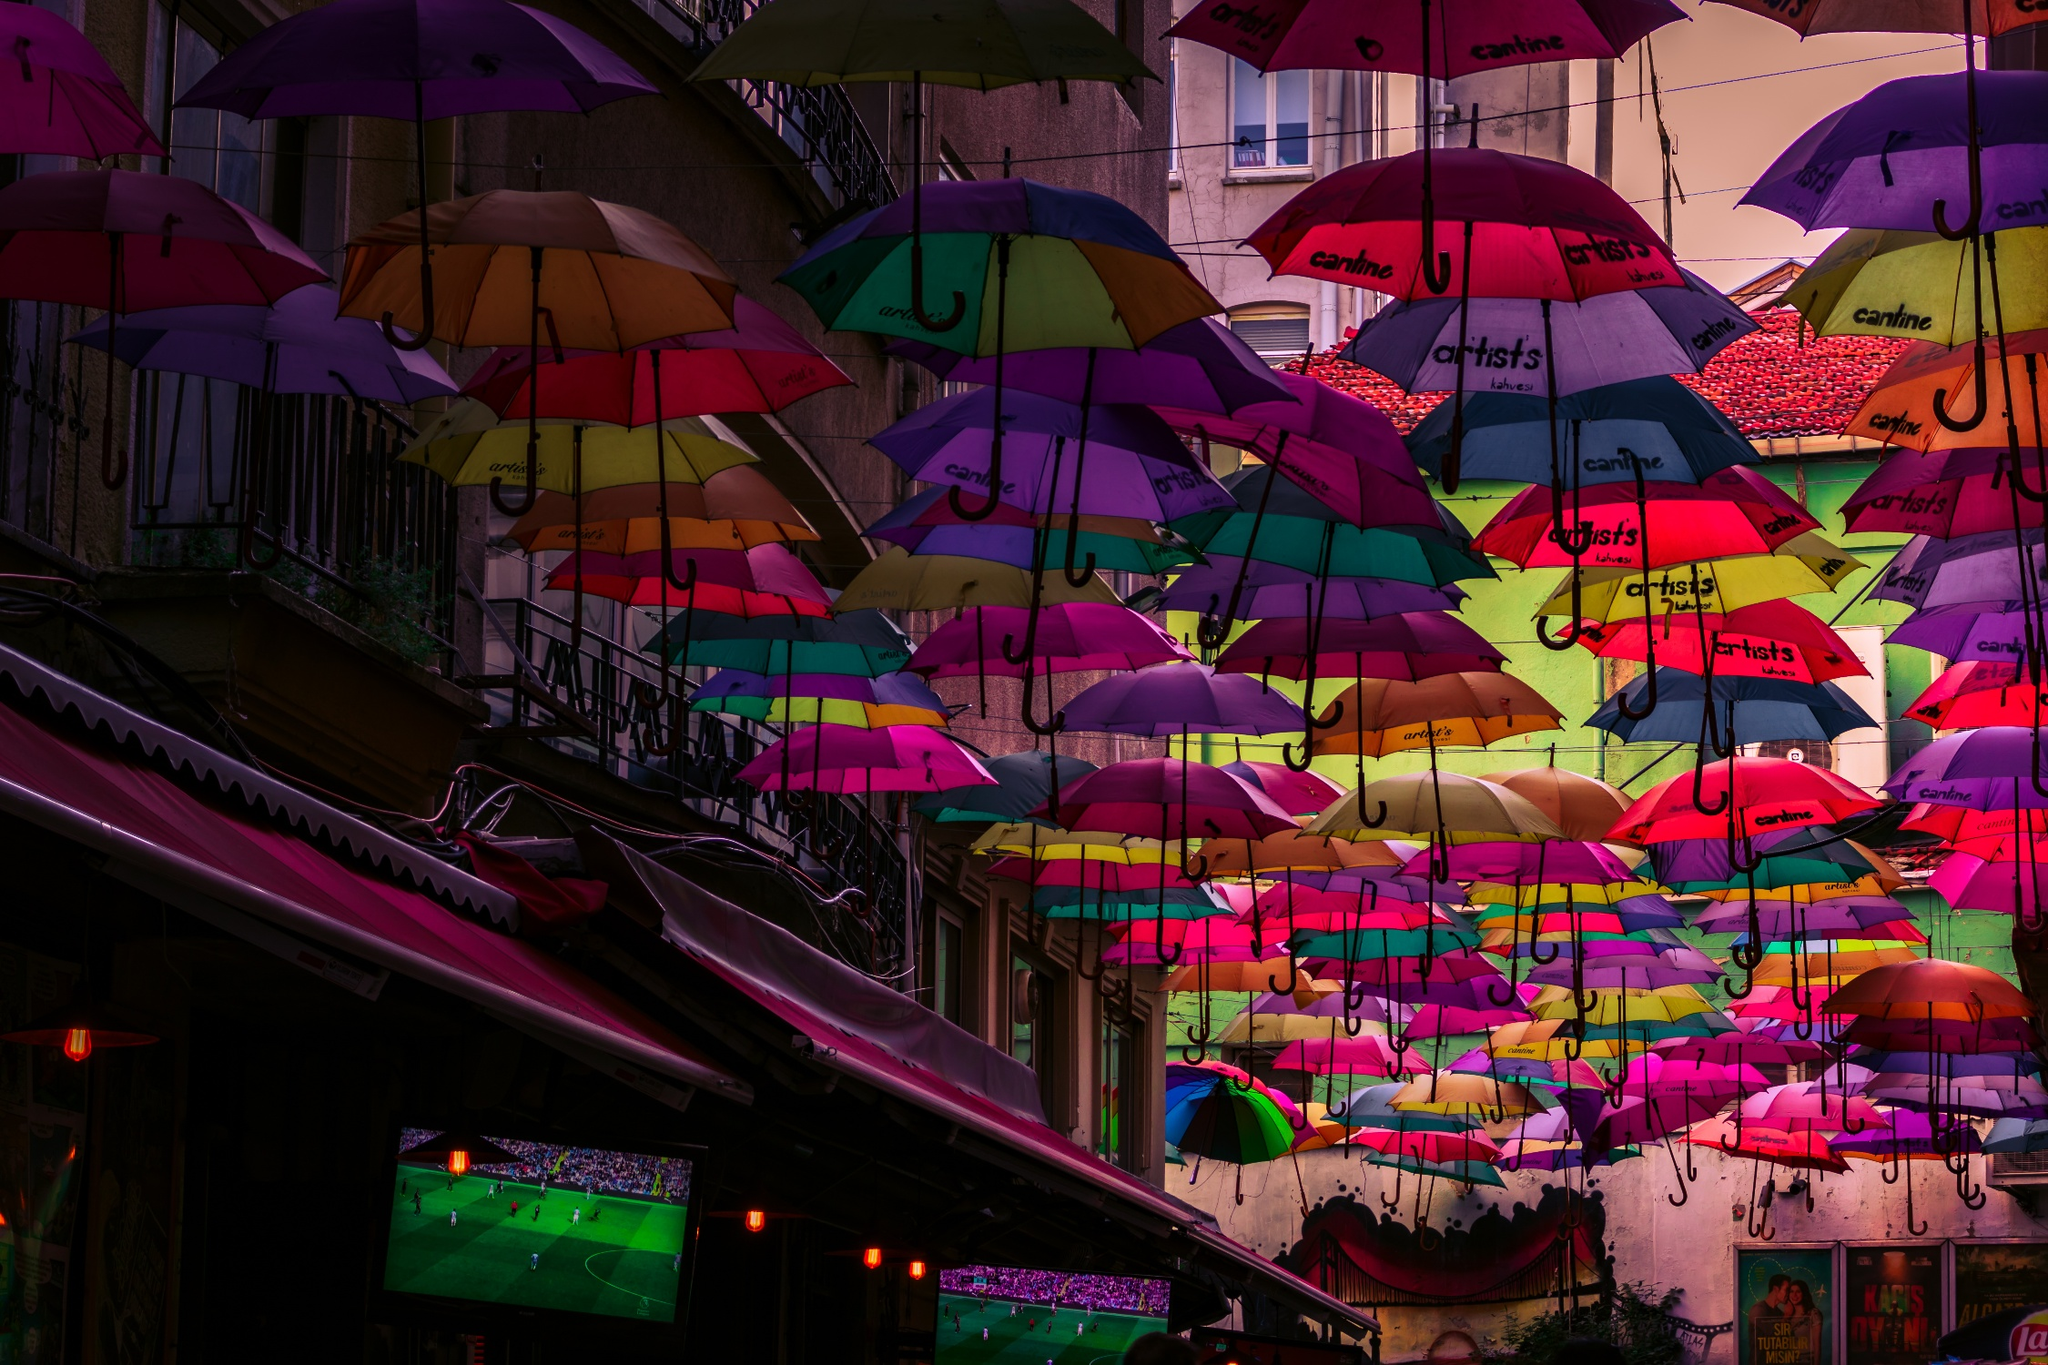What might be the impact of art installations like this one on local businesses? Art installations like these can significantly boost local businesses by attracting foot traffic and encouraging both tourists and locals to spend more time in the area. The vibrant and unique visual appeal encourages people to explore nearby shops, cafes, and restaurants, often leading to increased sales. In addition, such installations can transform a local area into a scenic spot for photography, further promoting the location on social media platforms and indirectly benefiting the surrounding businesses. The community atmosphere created by these events can also lead to a heightened sense of local pride and support for small, local enterprises. 